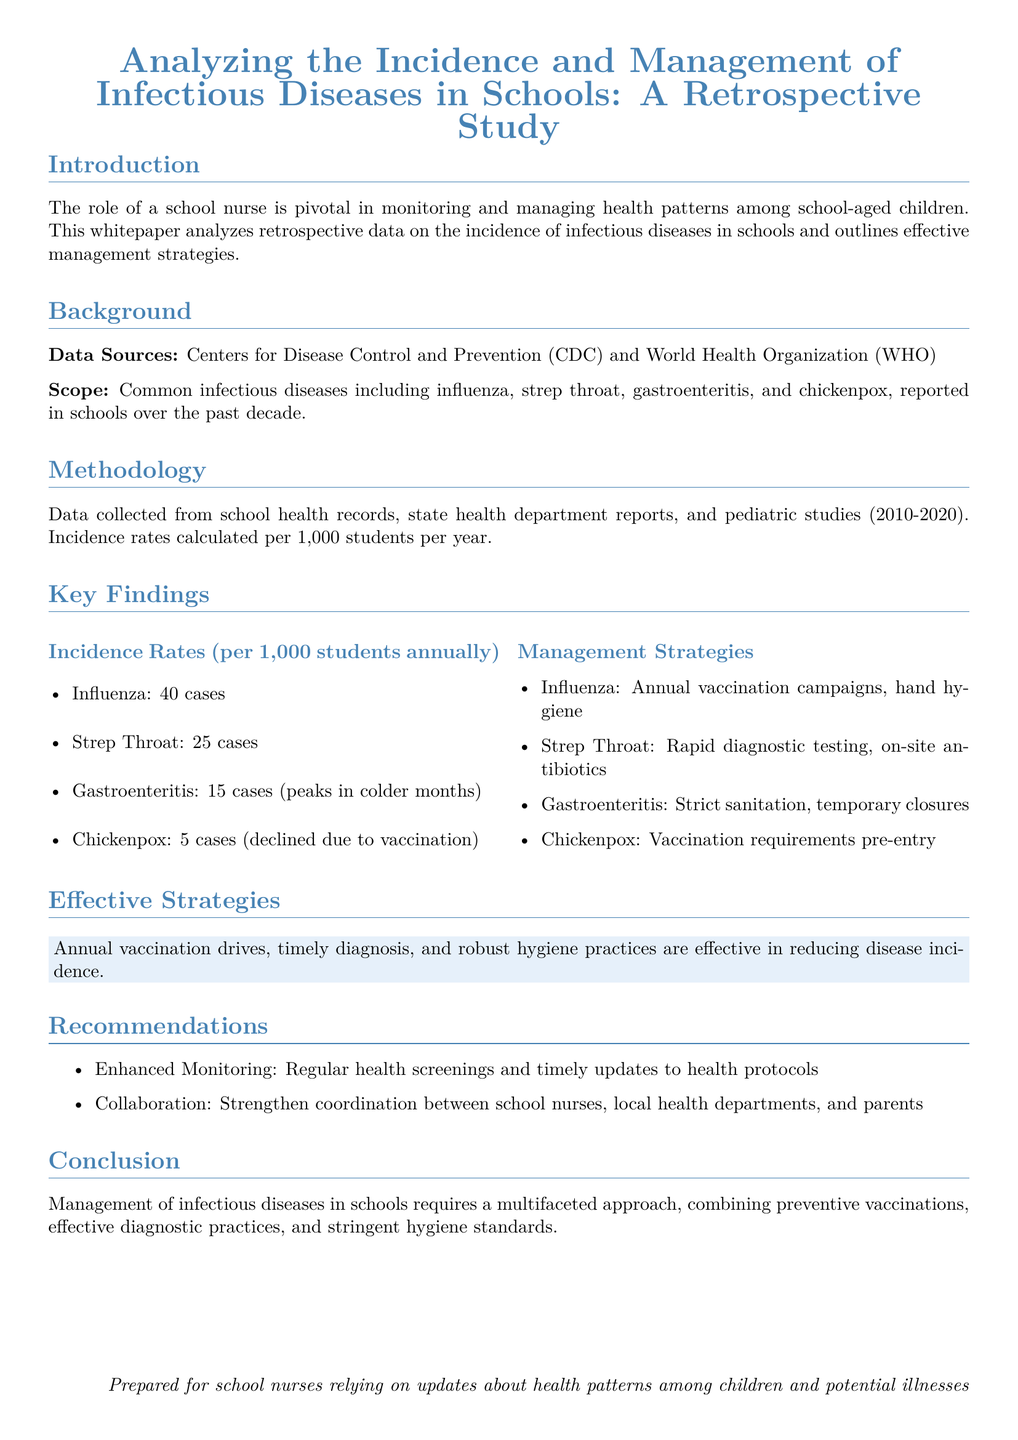what is the primary focus of the whitepaper? The primary focus of the whitepaper is to analyze the incidence and management of infectious diseases in schools.
Answer: incidence and management of infectious diseases in schools what are the data sources for this study? The data sources for this study are the Centers for Disease Control and Prevention (CDC) and World Health Organization (WHO).
Answer: CDC and WHO how many cases of influenza were reported per 1,000 students annually? The number of influenza cases reported annually was calculated per 1,000 students, which is 40 cases.
Answer: 40 cases what is the management strategy for gastroenteritis? The management strategy for gastroenteritis includes strict sanitation and temporary closures.
Answer: strict sanitation, temporary closures what year range does the collected data cover? The collected data covers the year range from 2010 to 2020.
Answer: 2010-2020 what has contributed to the decline in chickenpox cases? The decline in chickenpox cases is attributed to vaccination.
Answer: vaccination why are annual vaccination drives considered effective? Annual vaccination drives are effective because they help reduce the incidence of infectious diseases.
Answer: reduce disease incidence what are the recommendations provided in the whitepaper? The recommendations include enhanced monitoring and collaboration among health stakeholders.
Answer: Enhanced Monitoring and Collaboration what conclusion does the whitepaper draw about managing infectious diseases? The conclusion is that managing infectious diseases requires a multifaceted approach.
Answer: multifaceted approach 